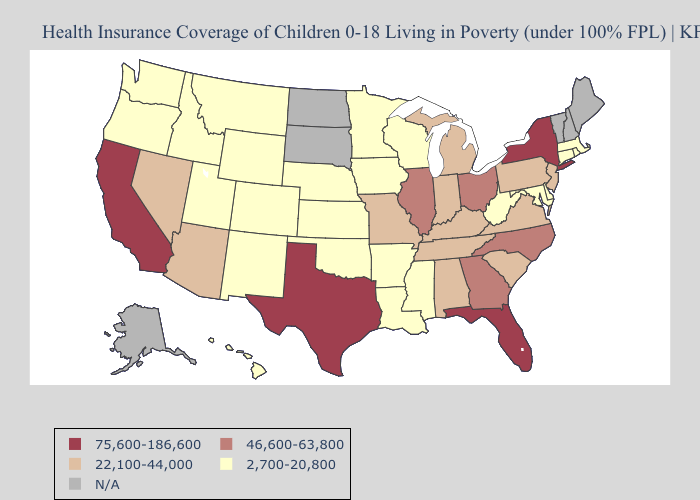What is the lowest value in states that border Iowa?
Quick response, please. 2,700-20,800. What is the highest value in the South ?
Write a very short answer. 75,600-186,600. What is the value of Indiana?
Short answer required. 22,100-44,000. What is the lowest value in the West?
Keep it brief. 2,700-20,800. What is the value of Maine?
Quick response, please. N/A. Name the states that have a value in the range 2,700-20,800?
Write a very short answer. Arkansas, Colorado, Connecticut, Delaware, Hawaii, Idaho, Iowa, Kansas, Louisiana, Maryland, Massachusetts, Minnesota, Mississippi, Montana, Nebraska, New Mexico, Oklahoma, Oregon, Rhode Island, Utah, Washington, West Virginia, Wisconsin, Wyoming. What is the value of Missouri?
Give a very brief answer. 22,100-44,000. Name the states that have a value in the range 46,600-63,800?
Keep it brief. Georgia, Illinois, North Carolina, Ohio. Does the map have missing data?
Be succinct. Yes. What is the value of Minnesota?
Be succinct. 2,700-20,800. Name the states that have a value in the range 22,100-44,000?
Quick response, please. Alabama, Arizona, Indiana, Kentucky, Michigan, Missouri, Nevada, New Jersey, Pennsylvania, South Carolina, Tennessee, Virginia. What is the value of Vermont?
Write a very short answer. N/A. What is the value of Montana?
Give a very brief answer. 2,700-20,800. 